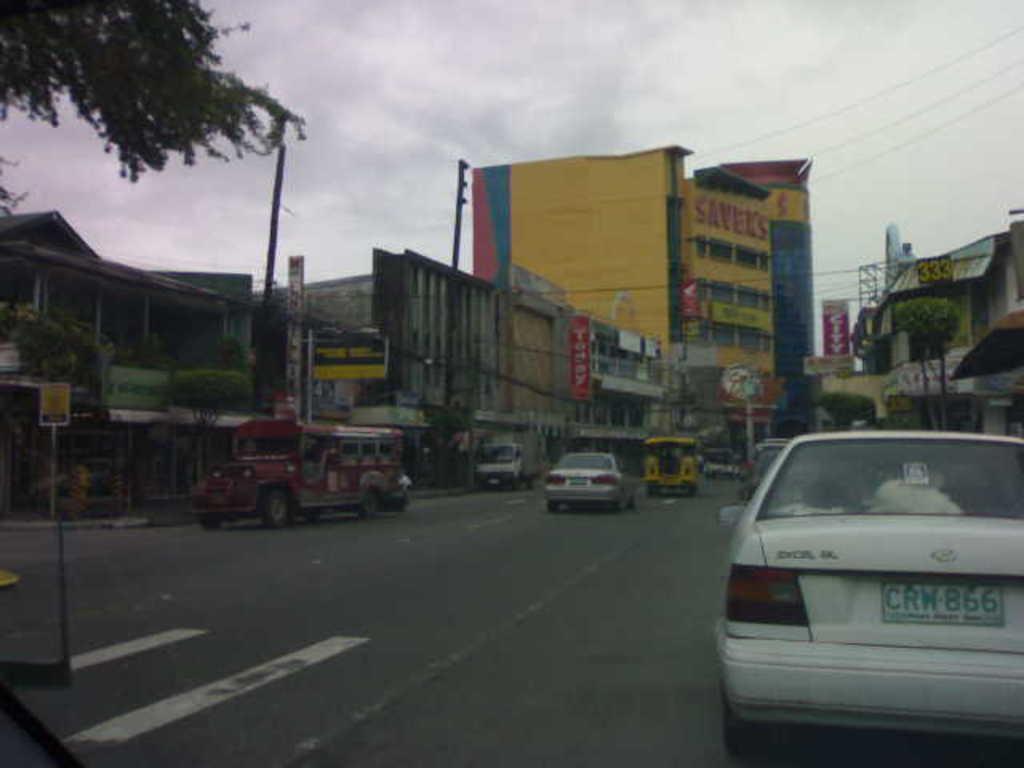In one or two sentences, can you explain what this image depicts? In this image we can see a few vehicles on the road, there are some buildings, poles, trees, wires and boards with some text on it, in the background we can see the sky with clouds. 